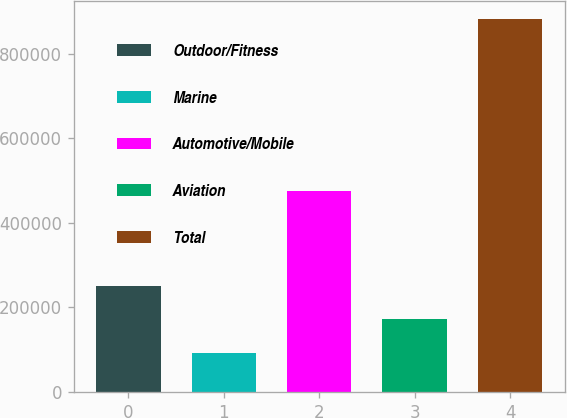Convert chart to OTSL. <chart><loc_0><loc_0><loc_500><loc_500><bar_chart><fcel>Outdoor/Fitness<fcel>Marine<fcel>Automotive/Mobile<fcel>Aviation<fcel>Total<nl><fcel>250839<fcel>92952<fcel>475191<fcel>171895<fcel>882386<nl></chart> 